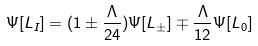Convert formula to latex. <formula><loc_0><loc_0><loc_500><loc_500>\Psi [ L _ { I } ] = ( 1 \pm { \frac { \Lambda } { 2 4 } } ) \Psi [ L _ { \pm } ] \mp { \frac { \Lambda } { 1 2 } } \Psi [ L _ { 0 } ]</formula> 